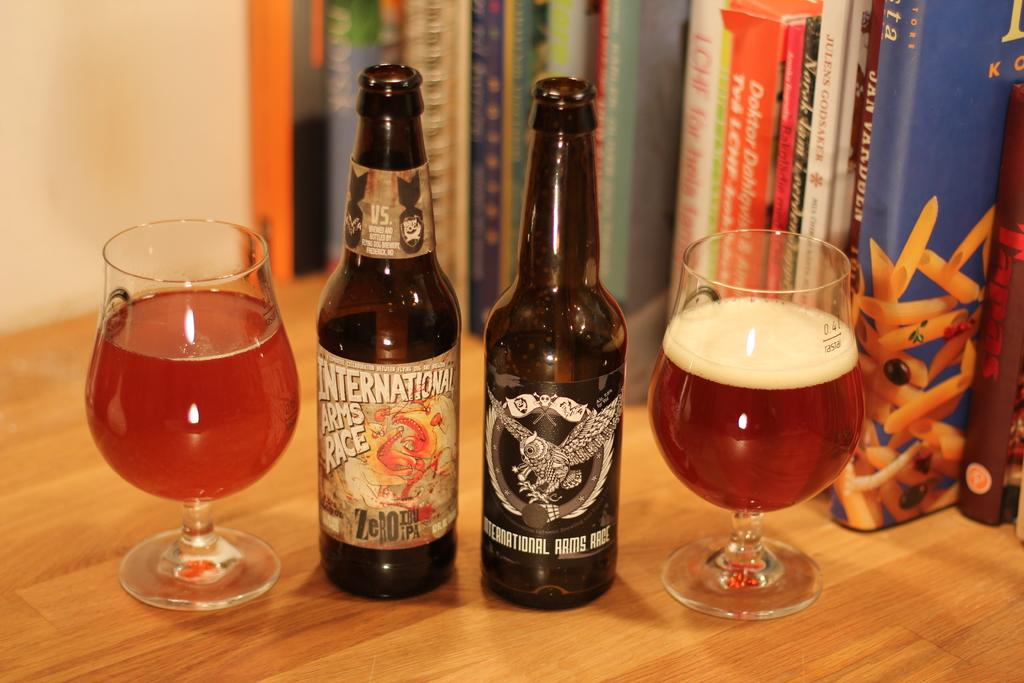<image>
Summarize the visual content of the image. a table with two bottles next to each other with one labeled as 'international arms race' 